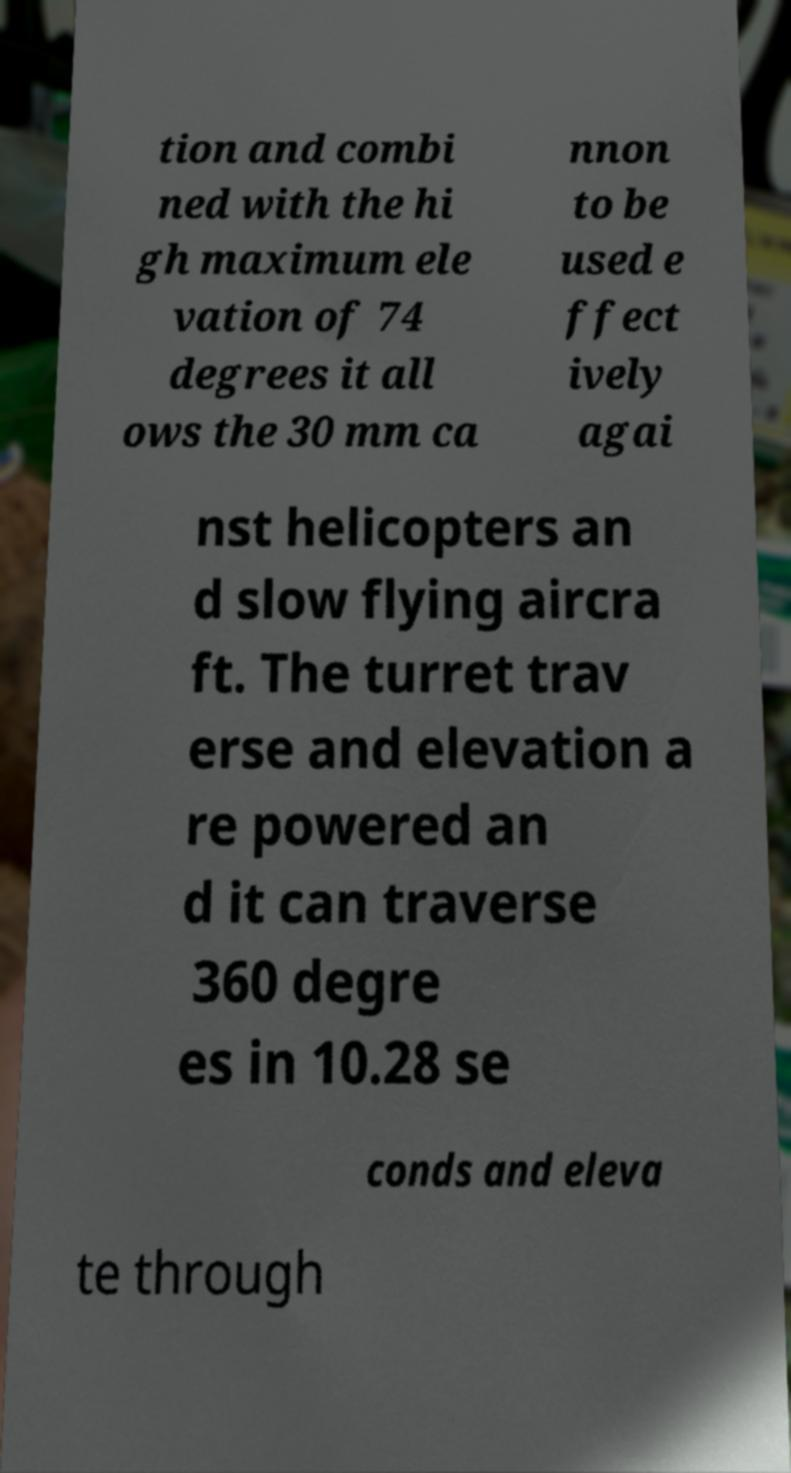What messages or text are displayed in this image? I need them in a readable, typed format. tion and combi ned with the hi gh maximum ele vation of 74 degrees it all ows the 30 mm ca nnon to be used e ffect ively agai nst helicopters an d slow flying aircra ft. The turret trav erse and elevation a re powered an d it can traverse 360 degre es in 10.28 se conds and eleva te through 